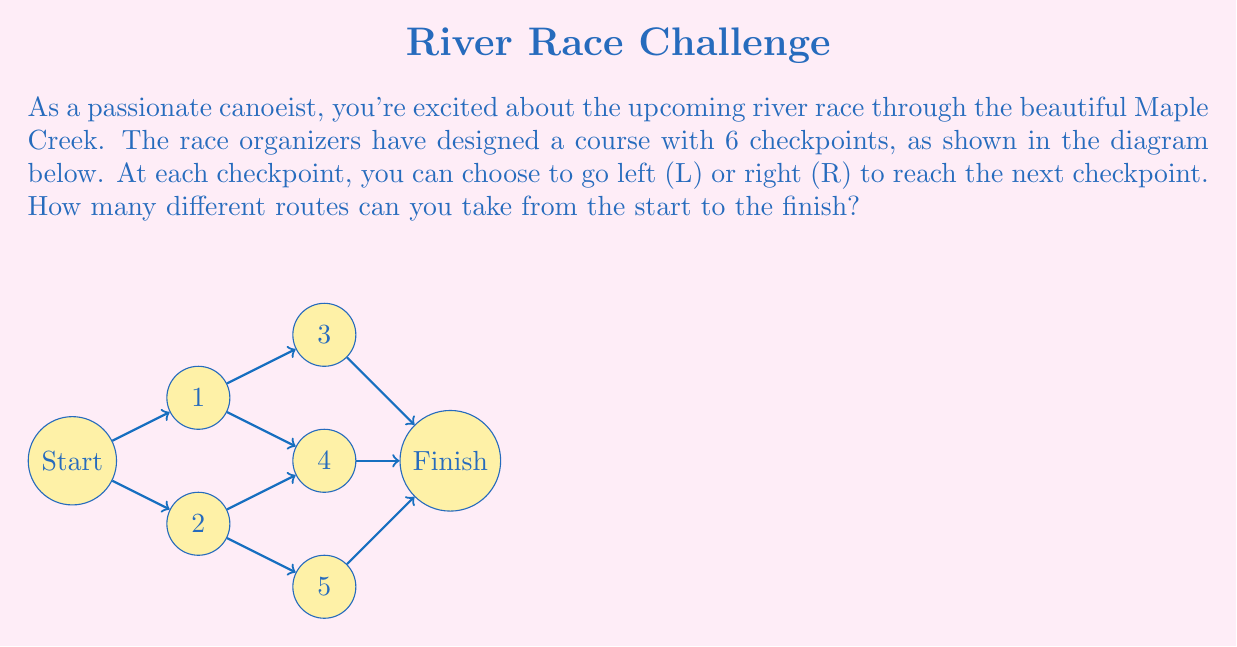Show me your answer to this math problem. Let's approach this step-by-step:

1) First, observe that to reach the finish, you must make 5 choices (one at the start and one at each of the 4 intermediate checkpoints).

2) At each choice point, you have 2 options: left (L) or right (R).

3) This scenario is a perfect application of the multiplication principle in combinatorics. When we have a sequence of independent choices, the total number of possibilities is the product of the number of options for each choice.

4) In this case, we have 5 independent choices, each with 2 options. So the total number of routes is:

   $$2 \times 2 \times 2 \times 2 \times 2 = 2^5$$

5) We can calculate this:

   $$2^5 = 32$$

6) To verify, we could list all possible routes:
   LLLLL, LLLLR, LLLRL, LLLRR, LLRLL, LLRLR, LLRRL, LLRRR,
   LRLLL, LRLLR, LRLRL, LRLRR, LRRLL, LRRLR, LRRRL, LRRRR,
   RLLLL, RLLLR, RLLRL, RLLRR, RLRLL, RLRLR, RLRRL, RLRRR,
   RRLLL, RRLLR, RRLRL, RRLRR, RRRLL, RRRLR, RRRRL, RRRRR

   Indeed, there are 32 different routes.

Therefore, there are 32 different routes you can take in this exciting canoe race!
Answer: $32$ 